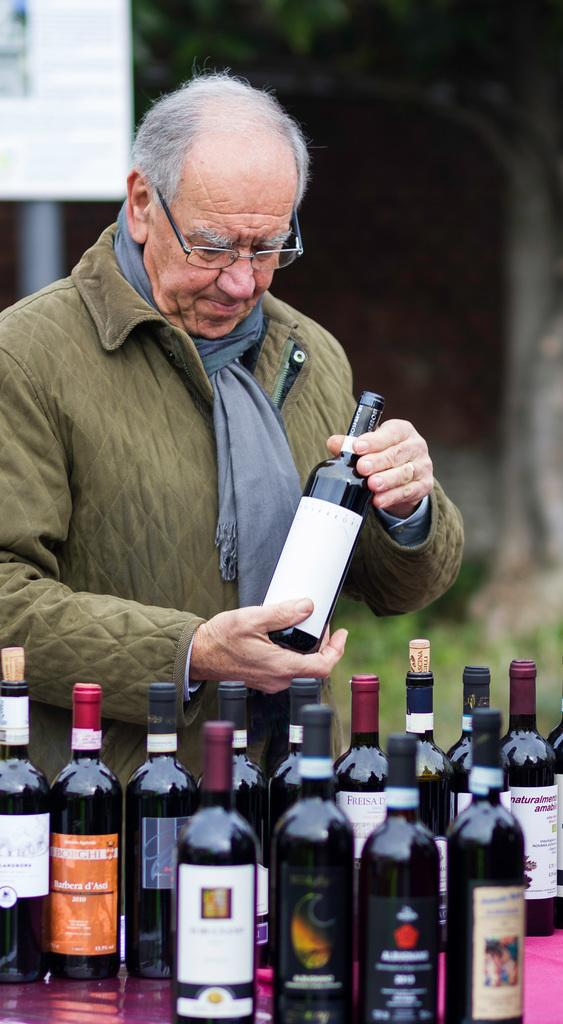Who is present in the image? There is a man in the image. What is the man holding in the image? The man is holding a wine bottle. Are there any other wine bottles visible in the image? Yes, there are additional wine bottles in the background. What type of advertisements can be seen in the image? There are hoardings visible in the image. What type of natural environment is present in the image? Grass and a tree are present in the image. What type of mine can be seen in the image? There is no mine present in the image. How does the guide help the man in the image? There is no guide present in the image. 